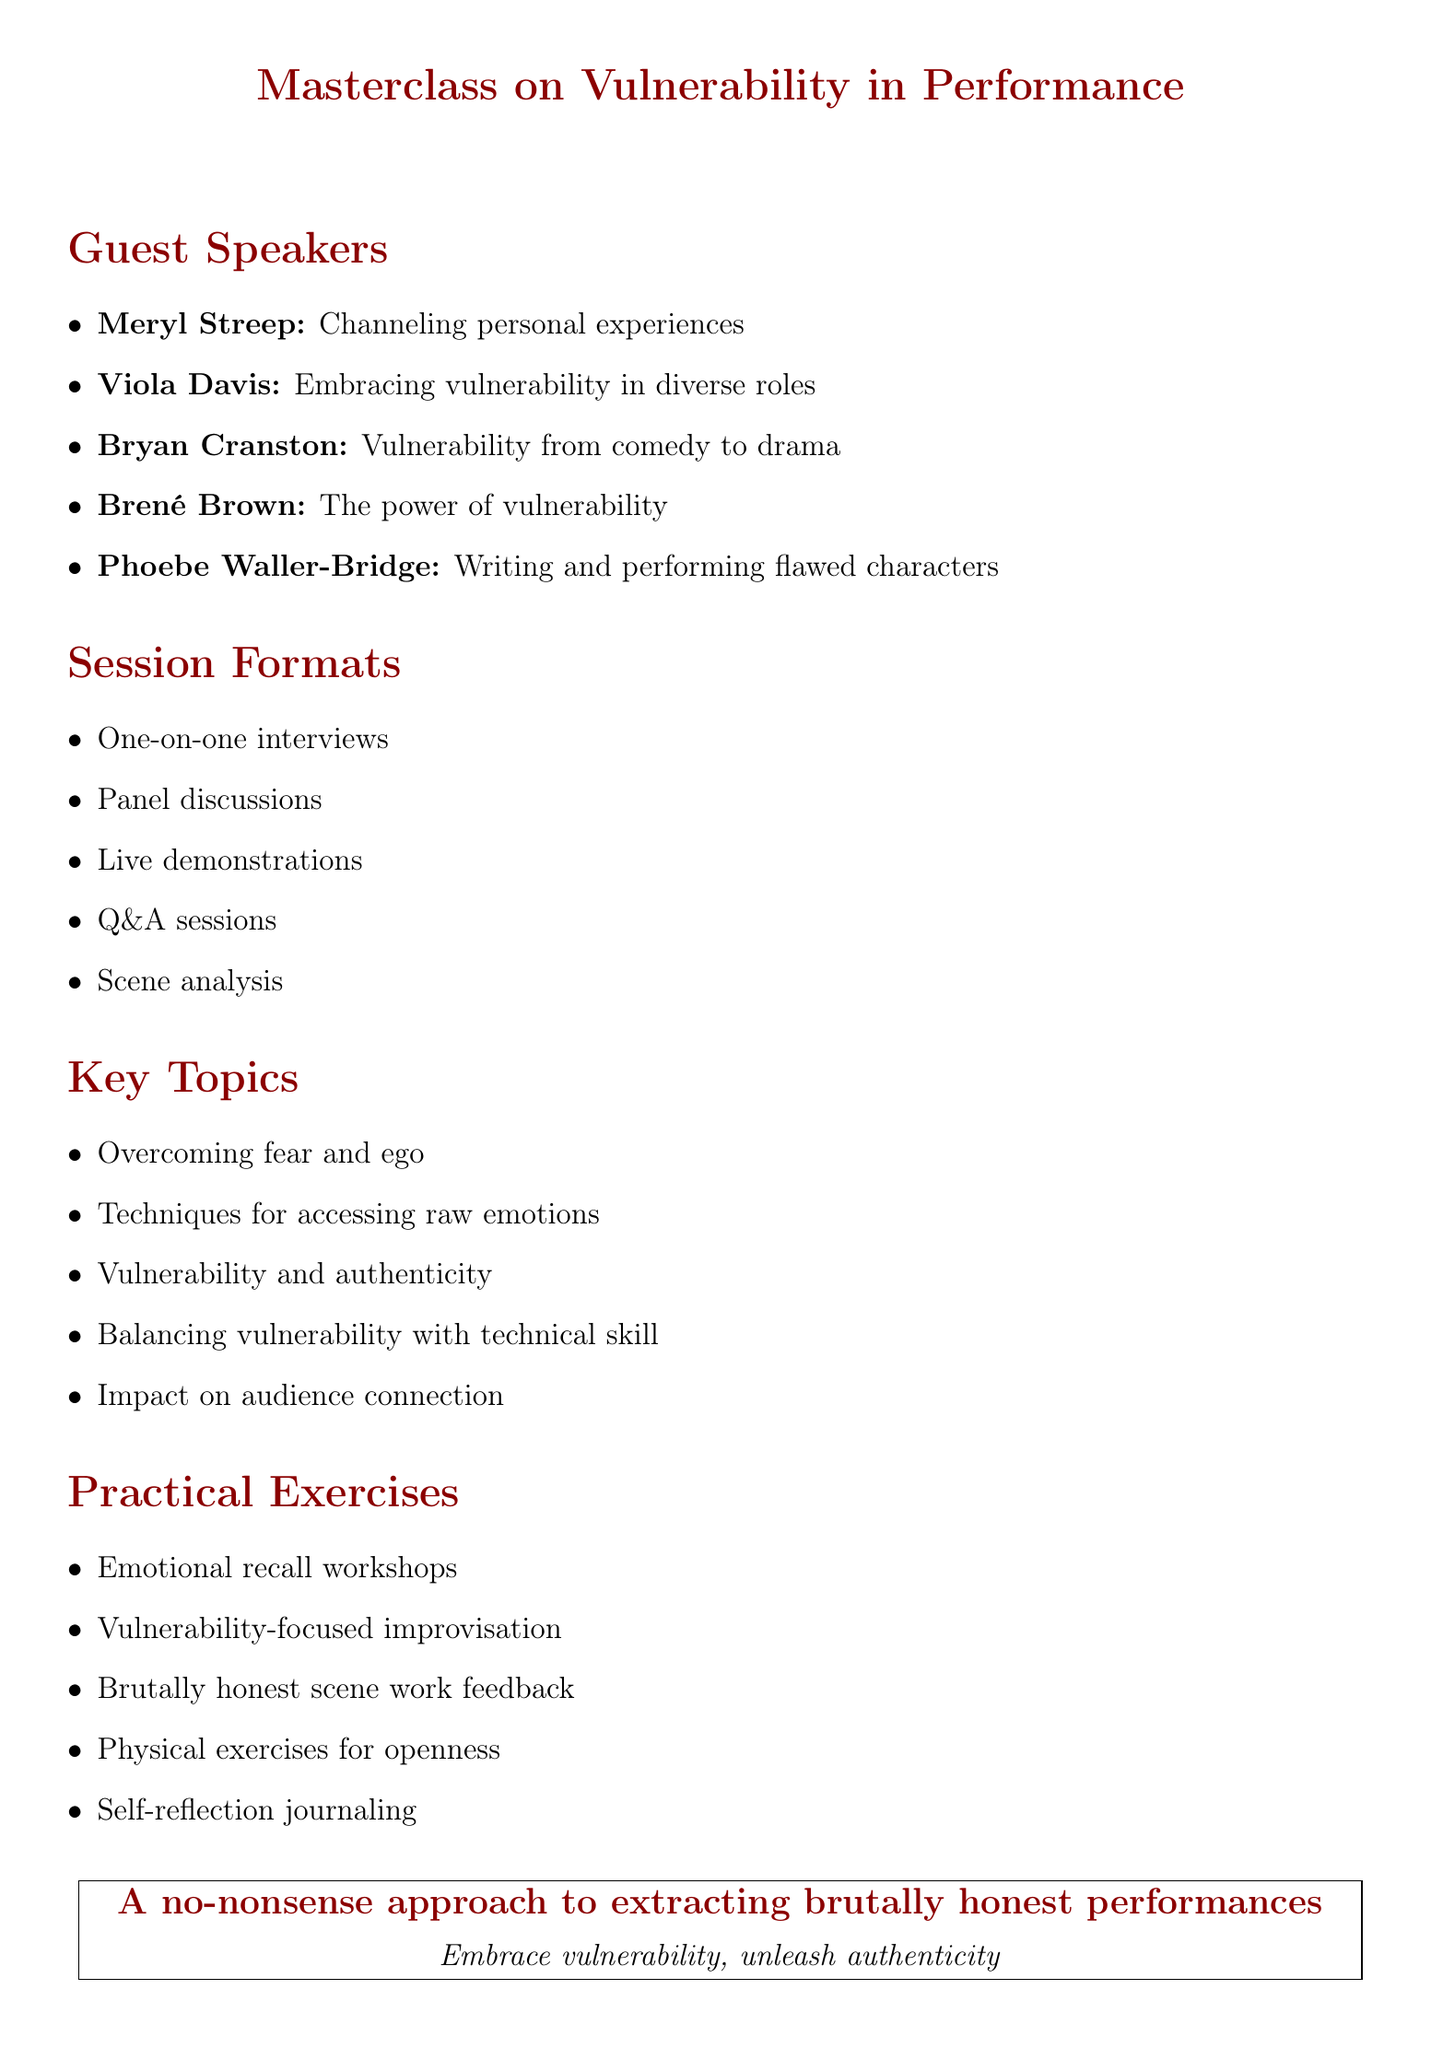What is the title of the masterclass? The title is explicitly stated at the beginning of the document.
Answer: Masterclass on Vulnerability in Performance Who is a guest speaker known for her intense character transformations? Meryl Streep is recognized for her intense character transformations as noted in the document.
Answer: Meryl Streep What award has Viola Davis won? The document mentions Viola Davis has won multiple awards, including an Emmy, Oscar, and Tony.
Answer: Emmy, Oscar, and Tony How many key topics are listed in the document? The document provides a number of key topics outlined clearly in a list format.
Answer: Eight What session format involves detailed performance feedback? The session formats include types that facilitate analyzing performances critically.
Answer: Scene analysis Who is known for emotional recall techniques? The document explicitly mentions the expertise of a renowned acting teacher concerning emotional recall.
Answer: Lee Strasberg What is the focus of Phoebe Waller-Bridge's discussion topic? The document specifies the focus of her discussion on writing and performing characters.
Answer: Writing and performing vulnerable, flawed characters Which practical exercise emphasizes personal vulnerabilities? The list of practical exercises highlights methods for self-exploration and vulnerability acknowledgment.
Answer: Self-reflection journaling 